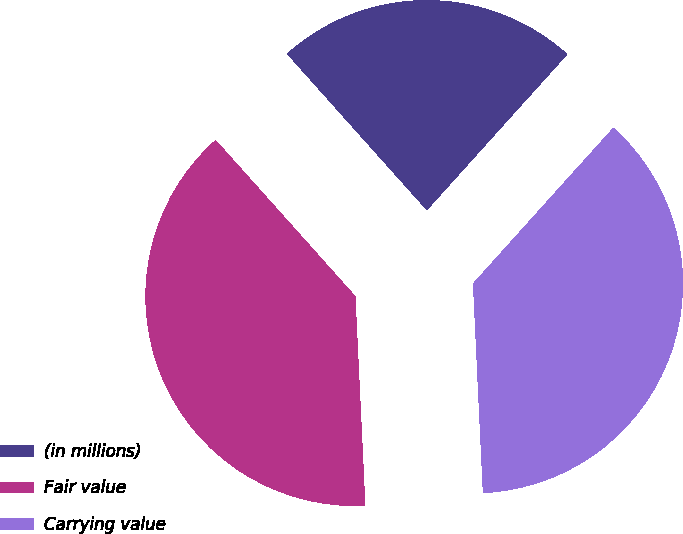Convert chart to OTSL. <chart><loc_0><loc_0><loc_500><loc_500><pie_chart><fcel>(in millions)<fcel>Fair value<fcel>Carrying value<nl><fcel>23.28%<fcel>39.14%<fcel>37.58%<nl></chart> 